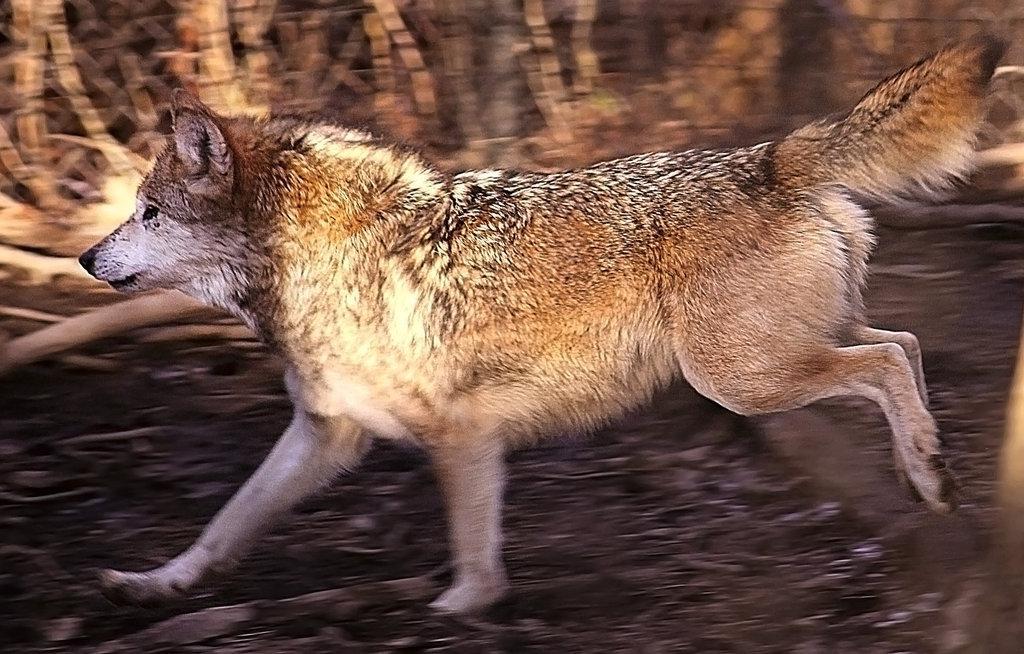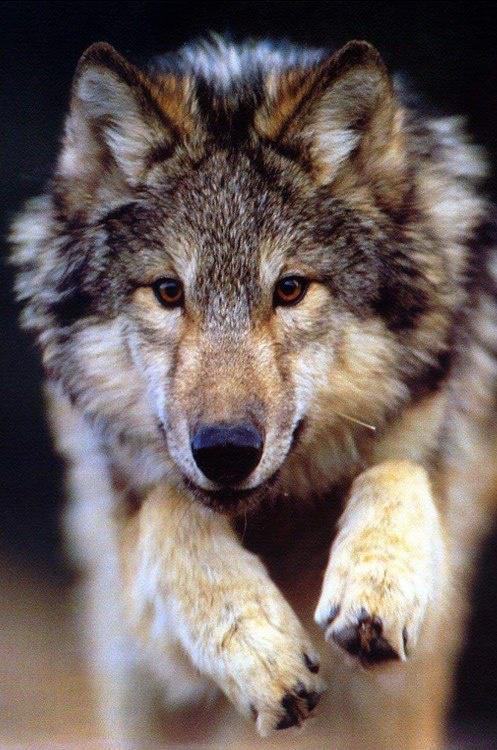The first image is the image on the left, the second image is the image on the right. Evaluate the accuracy of this statement regarding the images: "The combined images include two wolves in running poses.". Is it true? Answer yes or no. Yes. The first image is the image on the left, the second image is the image on the right. Assess this claim about the two images: "In one of the images, there is a wolf that is running.". Correct or not? Answer yes or no. Yes. 